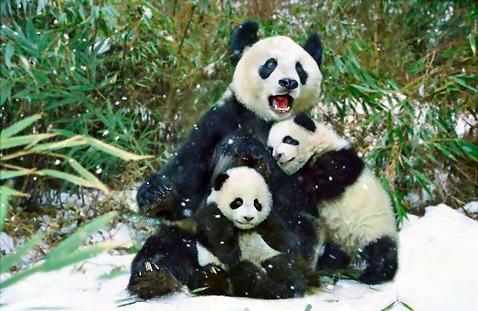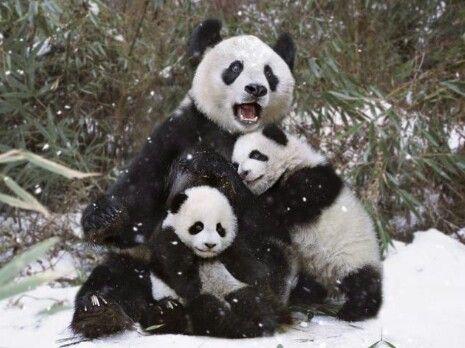The first image is the image on the left, the second image is the image on the right. Analyze the images presented: Is the assertion "There is at least one image where a single bear is animal is sitting alone." valid? Answer yes or no. No. The first image is the image on the left, the second image is the image on the right. For the images displayed, is the sentence "Some pandas are in the snow." factually correct? Answer yes or no. Yes. 